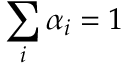<formula> <loc_0><loc_0><loc_500><loc_500>\sum _ { i } \alpha _ { i } = 1</formula> 